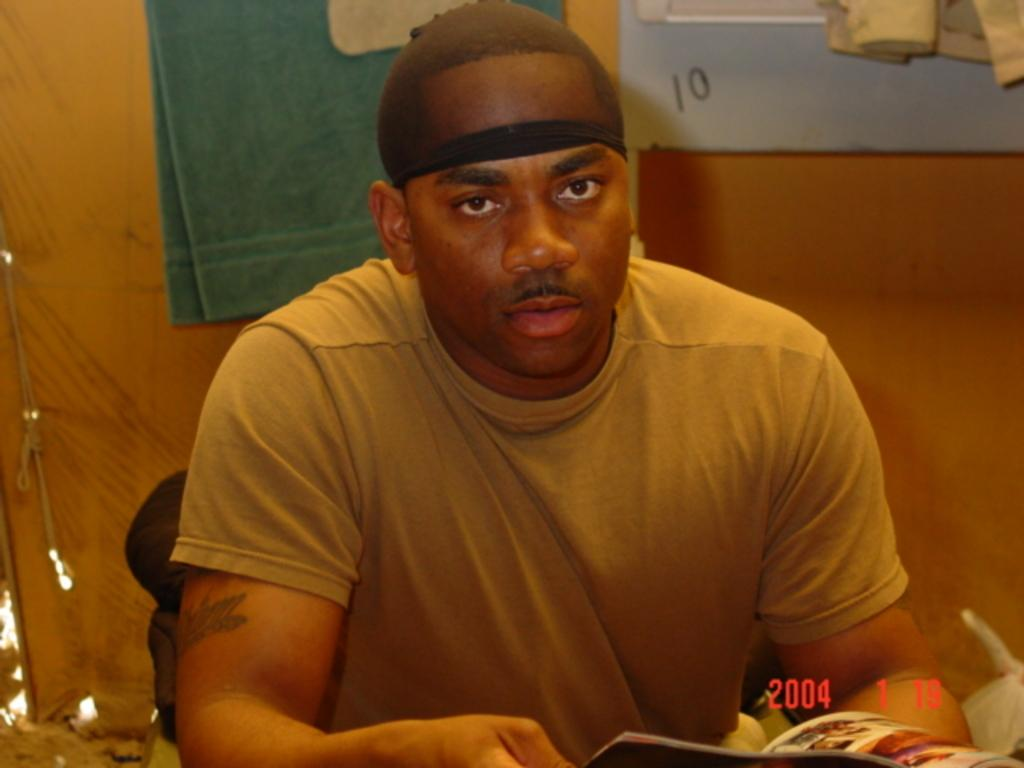What is the man in the image doing? The man is sitting in the image. What is the man holding in the image? The man is holding a book. What type of clothing is the man wearing? The man is wearing a t-shirt. What can be seen in the background of the image? There is a wall and a board in the background of the image. What other item is present in the image? There is a towel in the image. What type of jelly is the man using to care for his desk in the image? There is no jelly or desk present in the image. How does the man show care for the board in the background of the image? The image does not show the man interacting with the board, so it cannot be determined how he might show care for it. 